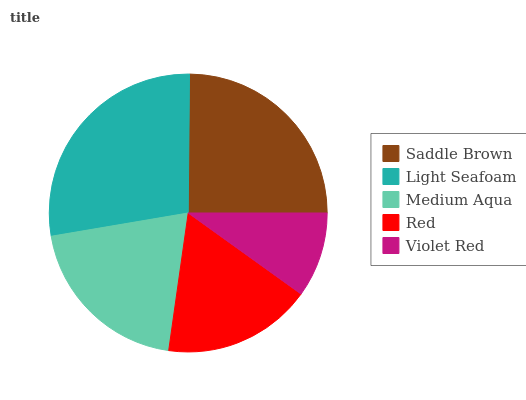Is Violet Red the minimum?
Answer yes or no. Yes. Is Light Seafoam the maximum?
Answer yes or no. Yes. Is Medium Aqua the minimum?
Answer yes or no. No. Is Medium Aqua the maximum?
Answer yes or no. No. Is Light Seafoam greater than Medium Aqua?
Answer yes or no. Yes. Is Medium Aqua less than Light Seafoam?
Answer yes or no. Yes. Is Medium Aqua greater than Light Seafoam?
Answer yes or no. No. Is Light Seafoam less than Medium Aqua?
Answer yes or no. No. Is Medium Aqua the high median?
Answer yes or no. Yes. Is Medium Aqua the low median?
Answer yes or no. Yes. Is Violet Red the high median?
Answer yes or no. No. Is Light Seafoam the low median?
Answer yes or no. No. 